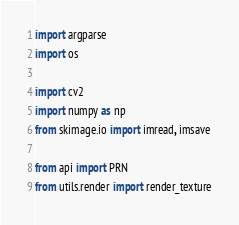<code> <loc_0><loc_0><loc_500><loc_500><_Python_>import argparse
import os

import cv2
import numpy as np
from skimage.io import imread, imsave

from api import PRN
from utils.render import render_texture

</code> 